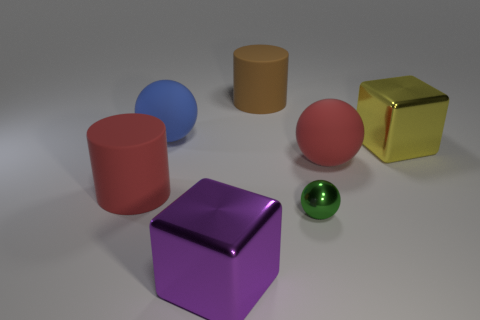Subtract all large balls. How many balls are left? 1 Subtract all red balls. How many balls are left? 2 Add 1 large purple shiny cylinders. How many objects exist? 8 Subtract all cubes. How many objects are left? 5 Subtract 0 purple spheres. How many objects are left? 7 Subtract 1 cylinders. How many cylinders are left? 1 Subtract all purple blocks. Subtract all brown cylinders. How many blocks are left? 1 Subtract all big purple things. Subtract all purple metallic things. How many objects are left? 5 Add 4 big blue matte balls. How many big blue matte balls are left? 5 Add 5 large yellow things. How many large yellow things exist? 6 